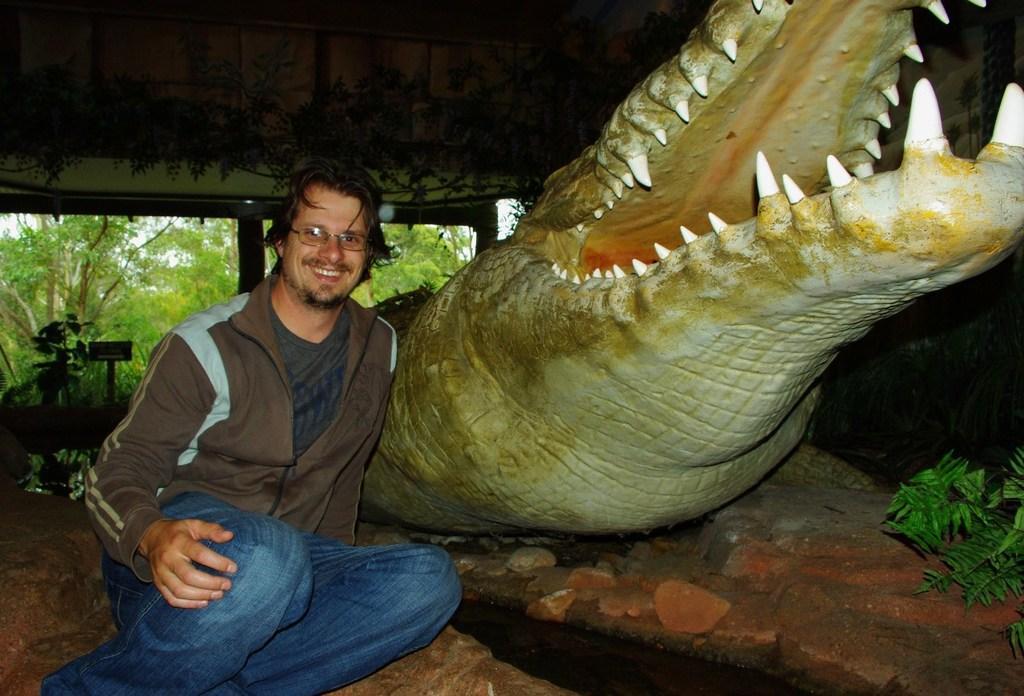Could you give a brief overview of what you see in this image? On the left side there is a person sitting and wearing a specs. Near to him there is a statue of a crocodile on a rock. On the right side there is a plant. In the background there are trees. At the top there is a wall with paintings. Also there are pillars. 